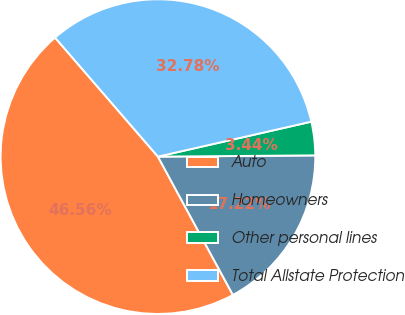<chart> <loc_0><loc_0><loc_500><loc_500><pie_chart><fcel>Auto<fcel>Homeowners<fcel>Other personal lines<fcel>Total Allstate Protection<nl><fcel>46.56%<fcel>17.22%<fcel>3.44%<fcel>32.78%<nl></chart> 